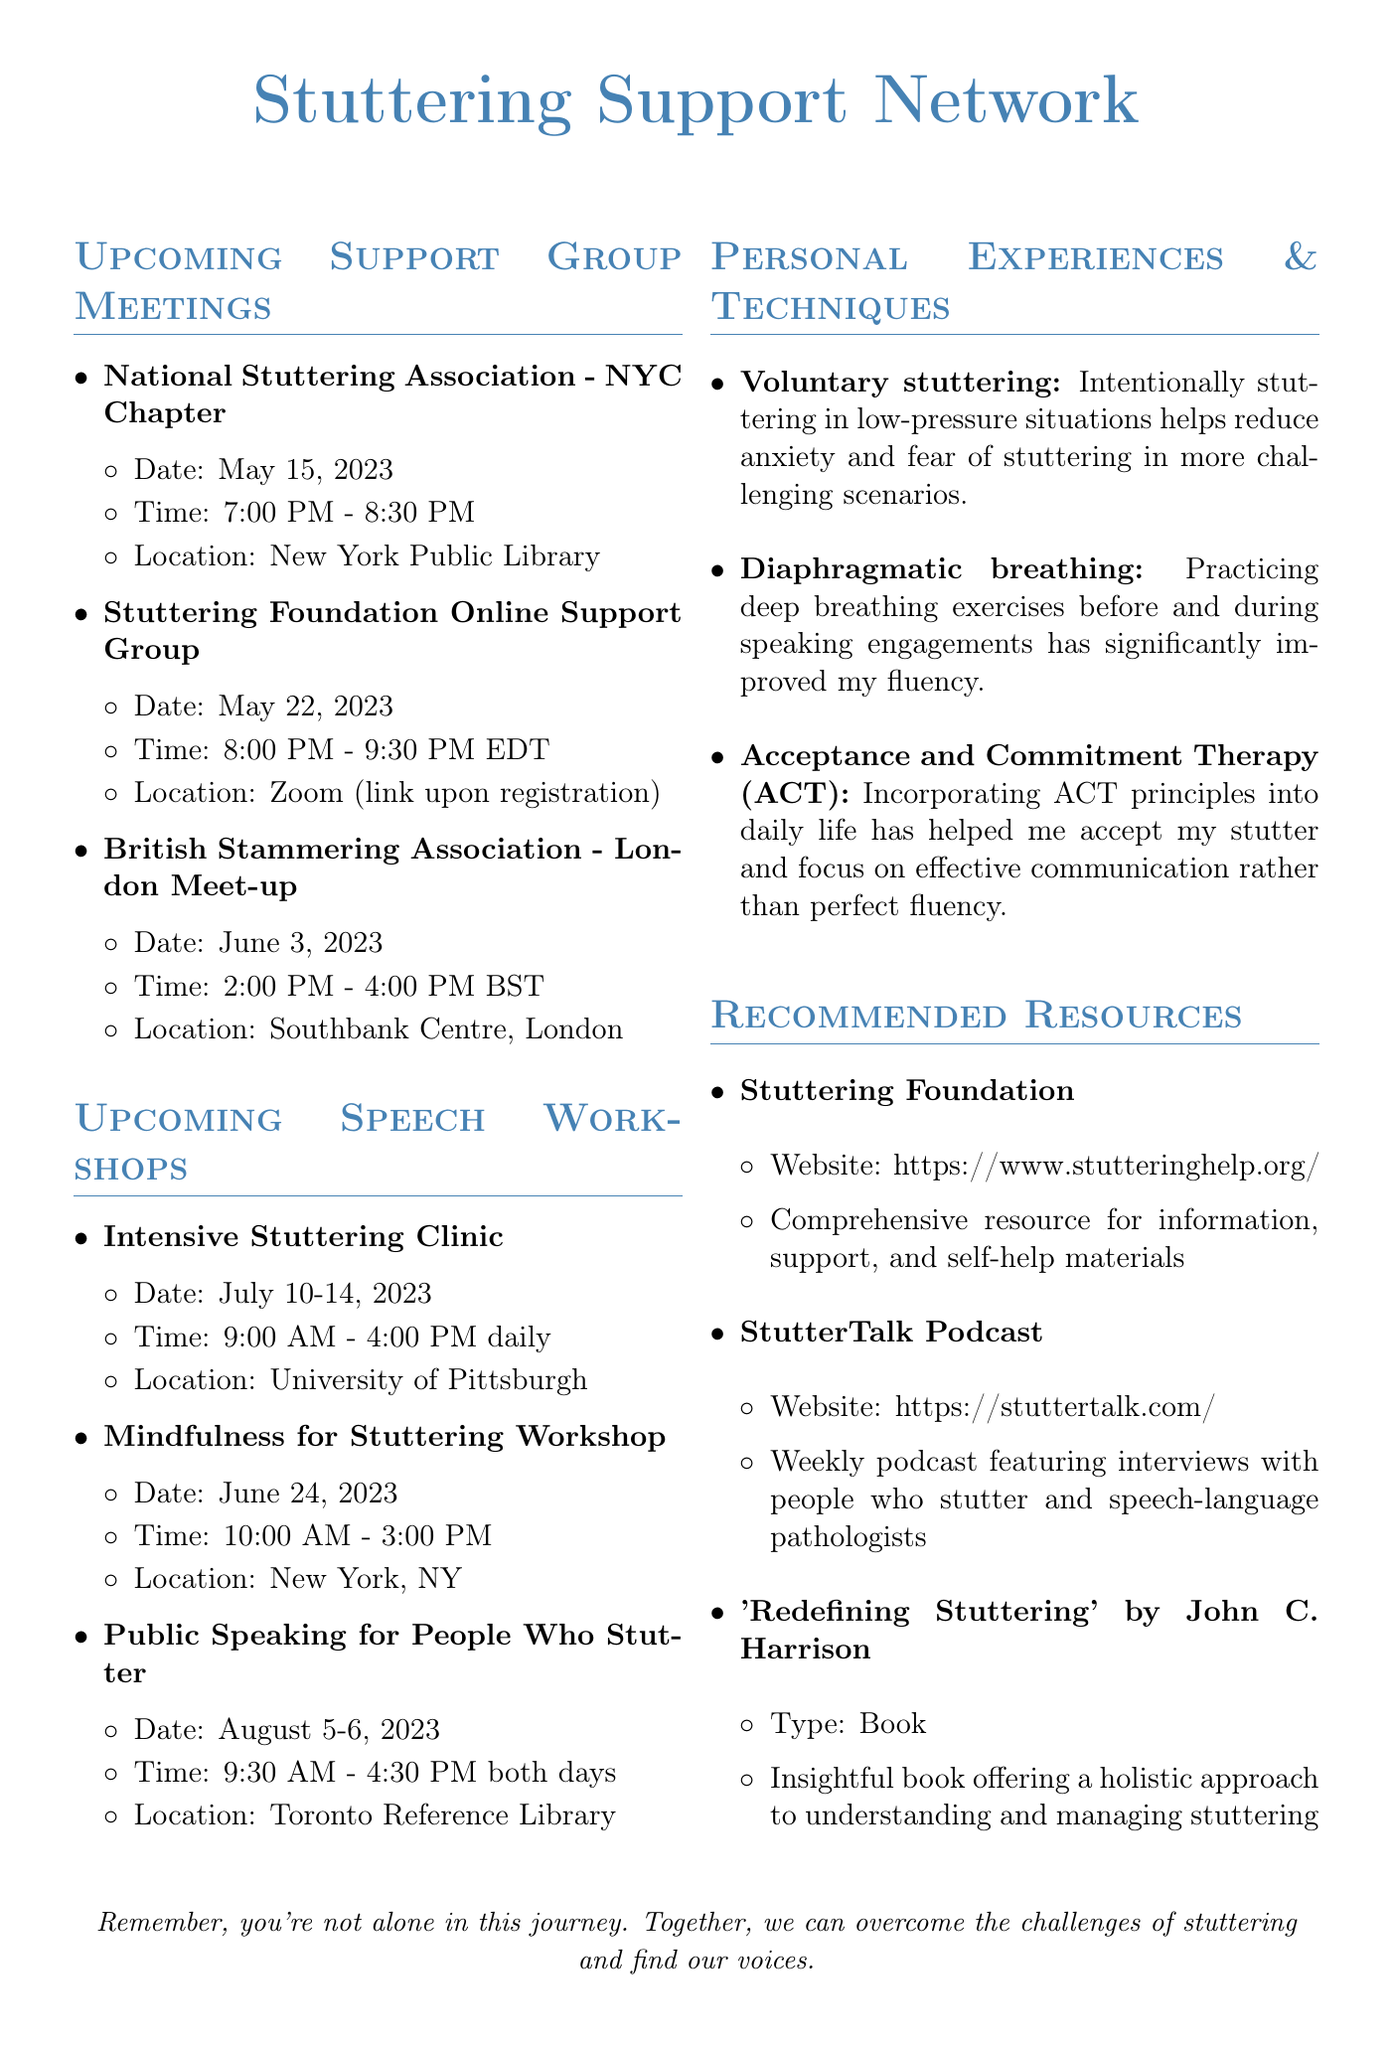What is the date of the National Stuttering Association meeting? The date is specifically mentioned under the support group meetings section.
Answer: May 15, 2023 What time does the Stuttering Foundation Online Support Group start? The time is listed alongside the meeting details.
Answer: 8:00 PM Where is the Mindfulness for Stuttering Workshop held? The location is provided in the details for the workshop.
Answer: 27 W 20th St #1203, New York, NY 10011 How many days does the Intensive Stuttering Clinic last? The duration of the workshop is outlined in its description.
Answer: Five days What technique is described as reducing anxiety through intentional stuttering? This technique is mentioned in the personal experiences section of the document.
Answer: Voluntary stuttering Which organization is hosting the Public Speaking for People Who Stutter workshop? The organizer is specified in the workshop details.
Answer: Canadian Stuttering Association What is the purpose of the British Stammering Association meet-up? This is explained in the description of the meet-up.
Answer: To connect and practice speaking What type of resource is the StutterTalk Podcast described as? The type of resource is indicated in the recommended resources section.
Answer: Weekly podcast 